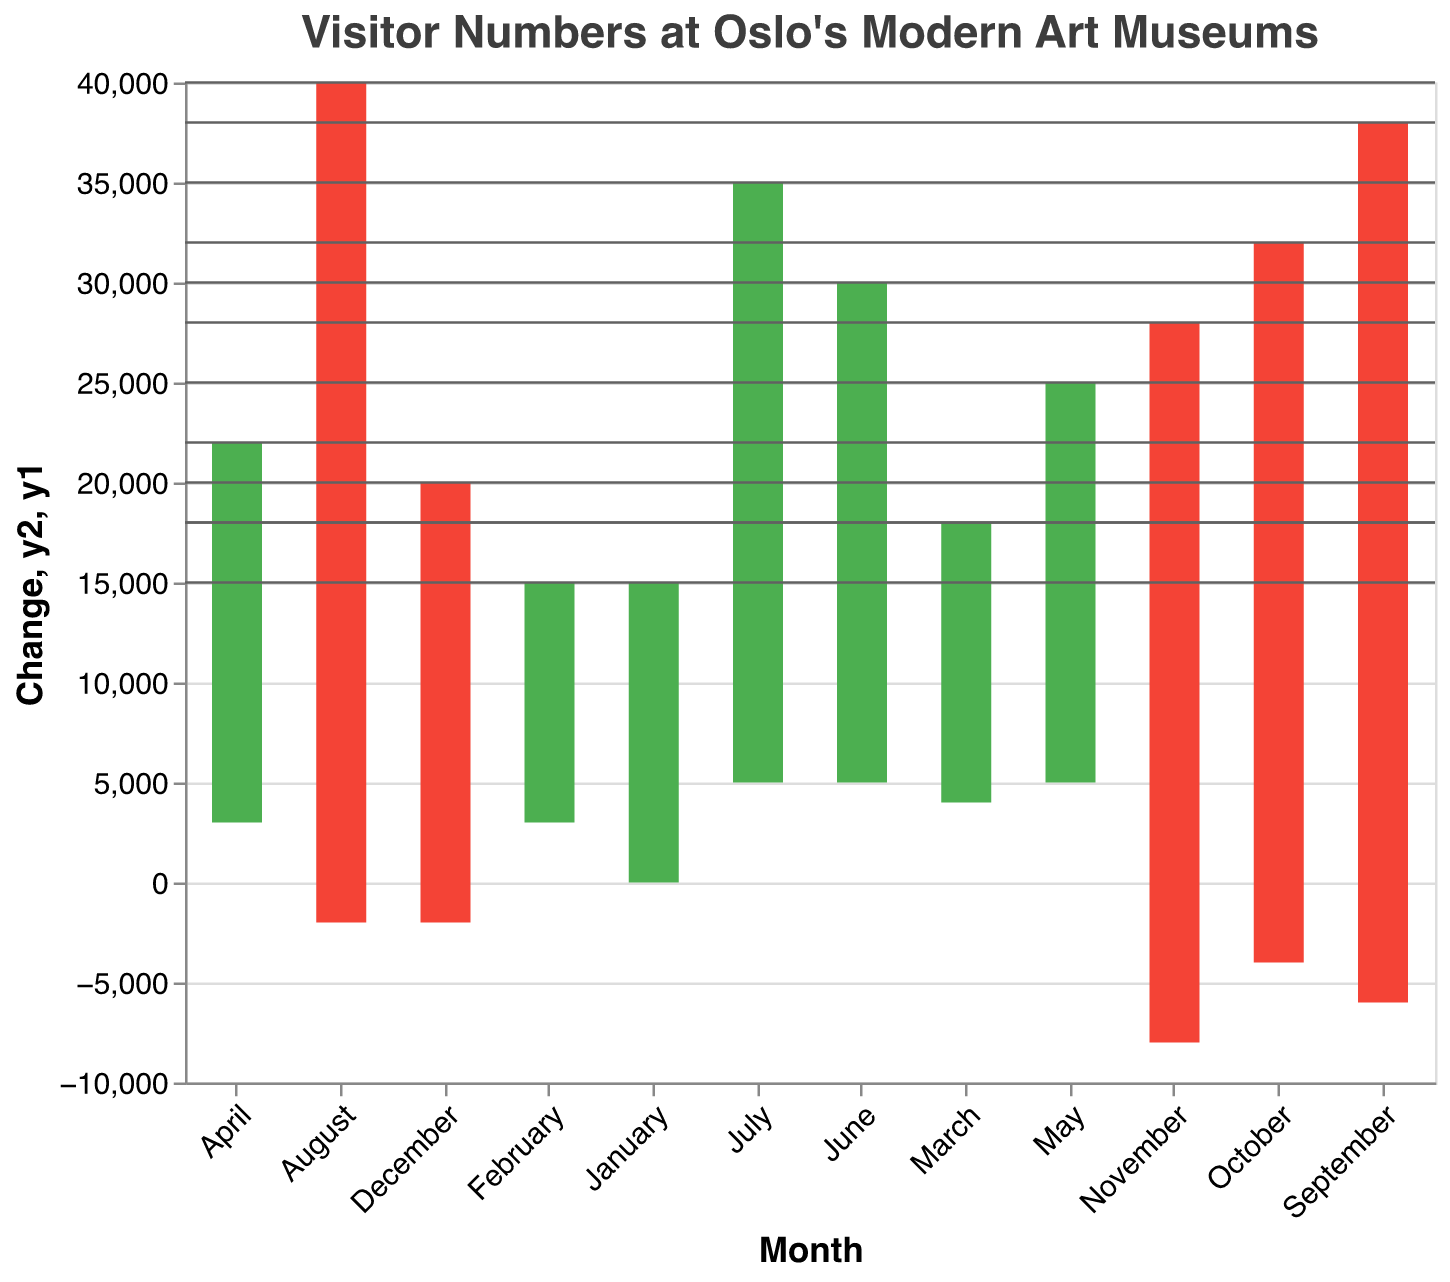What is the total number of visitors in January? The figure lists the number of visitors as 15,000 in January.
Answer: 15,000 During what month does the highest decrease in visitors occur? The figure shows the greatest negative change in November with a decrease of 8,000 visitors.
Answer: November What is the total number of visitors at the end of March? The figure shows the cumulative visitors for March is 22,000, calculated by summing changes: January (15,000) + February (3,000) + March (4,000).
Answer: 22,000 Which month has the highest increase in visitor numbers? By observing the positive changes, May, June, and July all have the highest increase of 5,000 visitors.
Answer: May, June, or July How many months show a decrease in visitor numbers? By counting the number of months with negative changes, we find 4 months: August, September, October, November, and December.
Answer: 5 What is the total number of visitors at the end of the year? By summing up the monthly changes, the total at the end of the year is 18,000. It's a cumulative process considering the changes month by month.
Answer: 18,000 In which month is the number of visitors higher: April or October? April has 25,000 visitors and October has 28,000 visitors, so October is higher.
Answer: October What is the rate of change in visitors between January and June? Calculate the difference in visitors from June and January, then divide by January's visitors, (35,000 - 15,000) / 15,000 = 1.33, which means a 133% increase.
Answer: 133% What was the monthly average number of visitors over the entire year? Sum all the end-of-month visitor numbers and divide by 12. (sum of data is 15000 + 18000 + 22000 + 25000 + 30000 + 35000 + 40000 + 38000 + 32000 + 28000 + 20000 + 18000 = 311,000, divided by 12 gives approximately 25,917 visitors per month.
Answer: 25,917 Between which two consecutive months is there the smallest change in visitor numbers? The figure shows data, and the smallest change is a decrease of 2,000 visitors from December to January. Another small change is from February to March as the change is +3000 and from January to February is 3000 and November to December is -2000 and July to August is -2000. So, the direct calculation and logic are that the change from July to August is -2000 which is accurately  the smallest decrease.
Answer: December to January; July to August; and November to December 